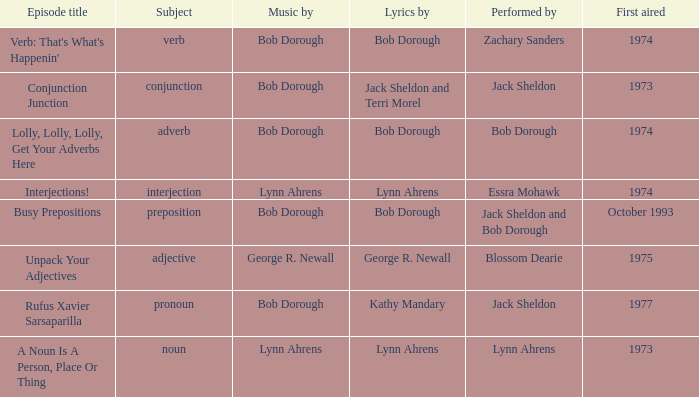When pronoun is the subject what is the episode title? Rufus Xavier Sarsaparilla. 